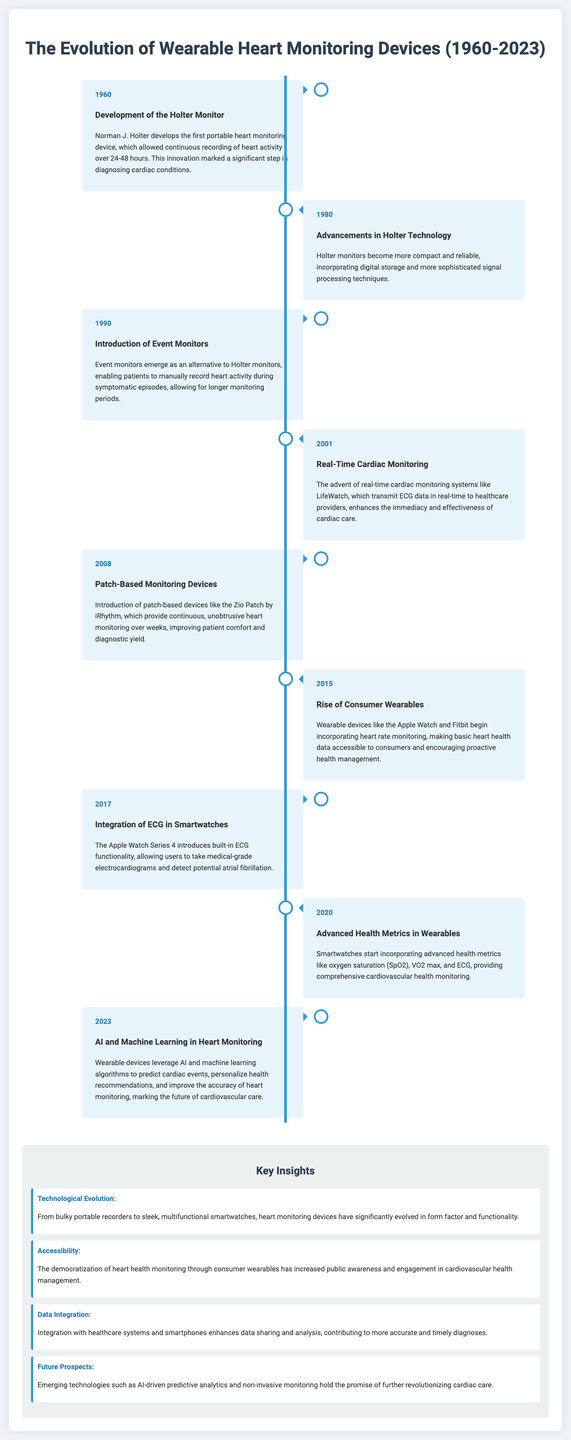What year was the Holter Monitor developed? The document states that the Holter Monitor was developed in 1960.
Answer: 1960 What significant advancement occurred in 2017 regarding smartwatches? In 2017, the Apple Watch Series 4 introduced built-in ECG functionality.
Answer: Built-in ECG functionality Which wearable device introduced advanced health metrics like oxygen saturation in 2020? The document mentions that smartwatches started incorporating advanced health metrics like SpO2 in 2020.
Answer: Smartwatches What key insight discusses the integration with healthcare systems? The document states that data integration contributes to more accurate and timely diagnoses.
Answer: Data Integration What is the main predictive technology expected to revolutionize cardiac care in the future? The document highlights AI-driven predictive analytics as the emerging technology for cardiac care.
Answer: AI-driven predictive analytics What was the purpose of event monitors introduced in 1990? Event monitors enabled patients to manually record heart activity during symptomatic episodes.
Answer: Manually record heart activity What year marks the rise of consumer wearables according to the timeline? The document indicates that the rise of consumer wearables occurred in 2015.
Answer: 2015 What does the term "Zio Patch" refer to? The Zio Patch is a patch-based device introduced in 2008 for continuous heart monitoring.
Answer: Patch-based device 